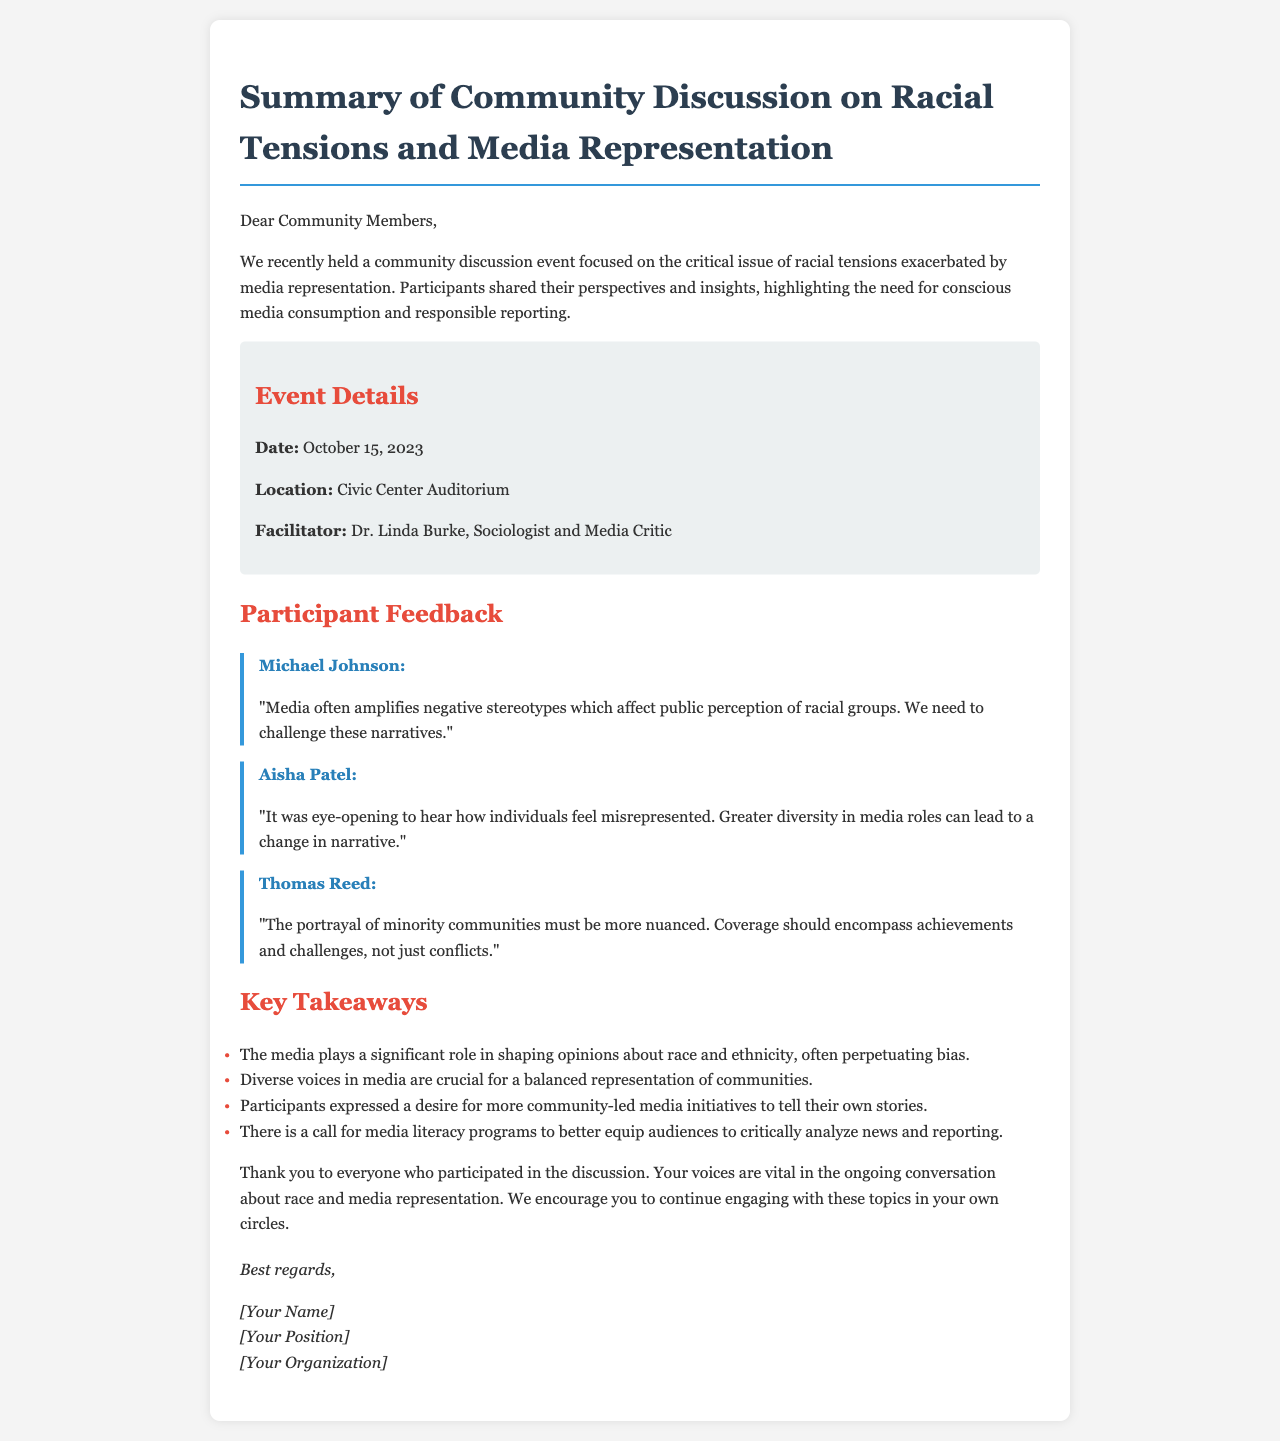What was the date of the event? The date of the event is mentioned in the event details section of the document.
Answer: October 15, 2023 Who facilitated the community discussion? The facilitator's name is listed in the event details section.
Answer: Dr. Linda Burke What was a key takeaway regarding media representation? The key takeaways are listed under a separate section in the document.
Answer: The media plays a significant role in shaping opinions about race and ethnicity, often perpetuating bias What is one of the participant's feedback regarding media roles? The document contains direct quotes from participants' feedback.
Answer: Greater diversity in media roles can lead to a change in narrative How many feedback quotes are provided in the document? The total number of quotes can be counted from the feedback section.
Answer: Three What is the location of the event? The location is specified in the event details section of the document.
Answer: Civic Center Auditorium What does Thomas Reed suggest about minority community portrayal? Thomas Reed's feedback focuses on the portrayal of minority communities found in the document.
Answer: The portrayal of minority communities must be more nuanced What suggestion is mentioned for media literacy? The document includes key takeaways that discuss media literacy.
Answer: A call for media literacy programs to better equip audiences 